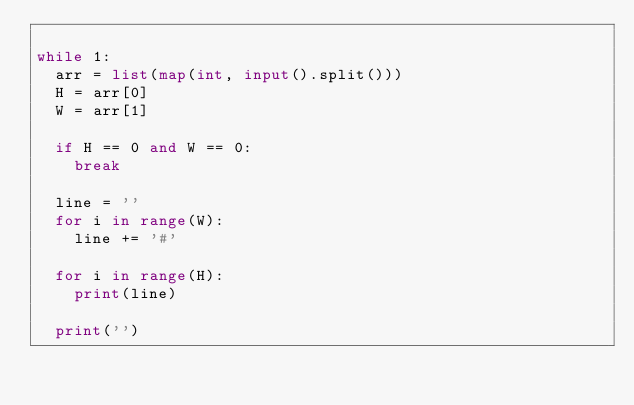Convert code to text. <code><loc_0><loc_0><loc_500><loc_500><_Python_>
while 1:
	arr = list(map(int, input().split()))
	H = arr[0]
	W = arr[1]
	
	if H == 0 and W == 0:
		break

	line = ''
	for i in range(W):
		line += '#'
	
	for i in range(H):
		print(line)

	print('')

</code> 